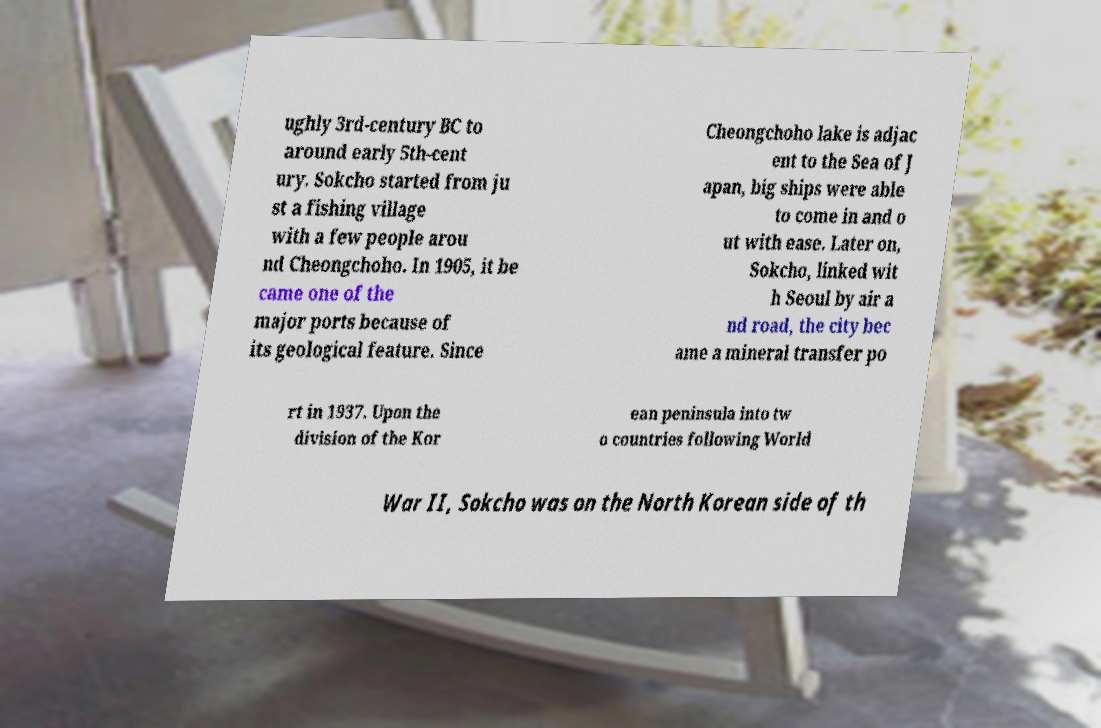For documentation purposes, I need the text within this image transcribed. Could you provide that? ughly 3rd-century BC to around early 5th-cent ury. Sokcho started from ju st a fishing village with a few people arou nd Cheongchoho. In 1905, it be came one of the major ports because of its geological feature. Since Cheongchoho lake is adjac ent to the Sea of J apan, big ships were able to come in and o ut with ease. Later on, Sokcho, linked wit h Seoul by air a nd road, the city bec ame a mineral transfer po rt in 1937. Upon the division of the Kor ean peninsula into tw o countries following World War II, Sokcho was on the North Korean side of th 